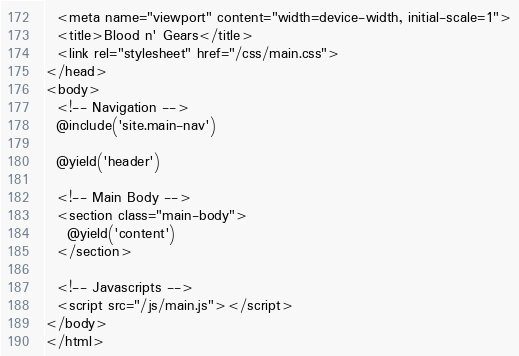Convert code to text. <code><loc_0><loc_0><loc_500><loc_500><_PHP_>  <meta name="viewport" content="width=device-width, initial-scale=1">
  <title>Blood n' Gears</title>
  <link rel="stylesheet" href="/css/main.css">
</head>
<body>
  <!-- Navigation -->
  @include('site.main-nav')

  @yield('header')

  <!-- Main Body -->
  <section class="main-body">
    @yield('content')
  </section>

  <!-- Javascripts -->
  <script src="/js/main.js"></script>
</body>
</html>
</code> 